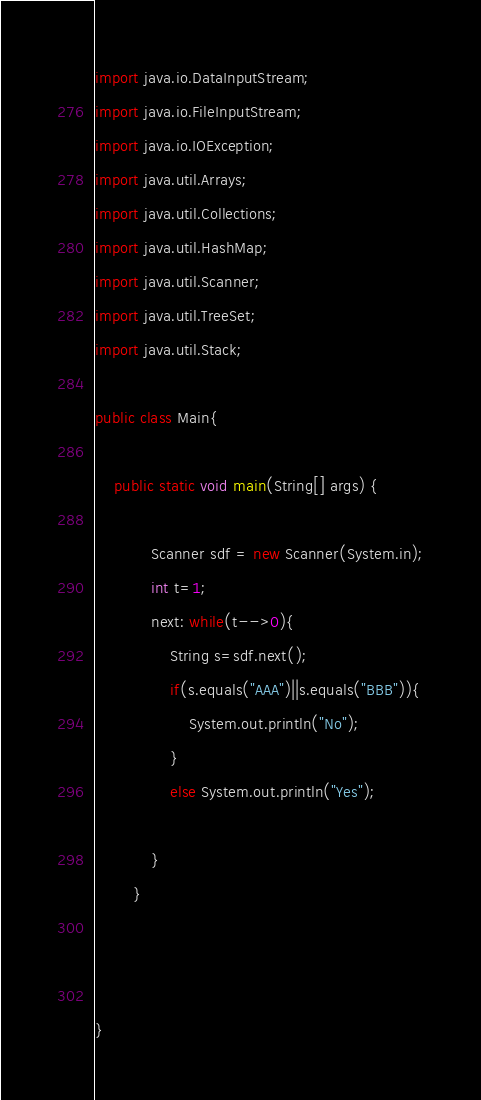Convert code to text. <code><loc_0><loc_0><loc_500><loc_500><_Java_>import java.io.DataInputStream;
import java.io.FileInputStream;
import java.io.IOException;
import java.util.Arrays;
import java.util.Collections;
import java.util.HashMap;
import java.util.Scanner;
import java.util.TreeSet;
import java.util.Stack;

public class Main{
       
	public static void main(String[] args) {
		
            Scanner sdf = new Scanner(System.in);
            int t=1;
            next: while(t-->0){
                String s=sdf.next();
                if(s.equals("AAA")||s.equals("BBB")){
                    System.out.println("No");
                }
                else System.out.println("Yes");
                    
            }
        }

        
        
}</code> 